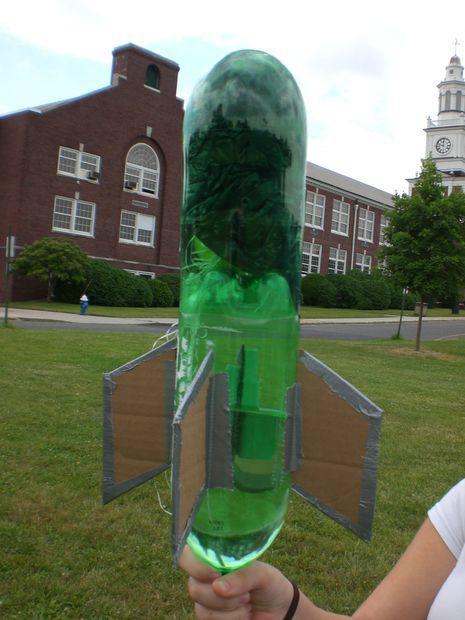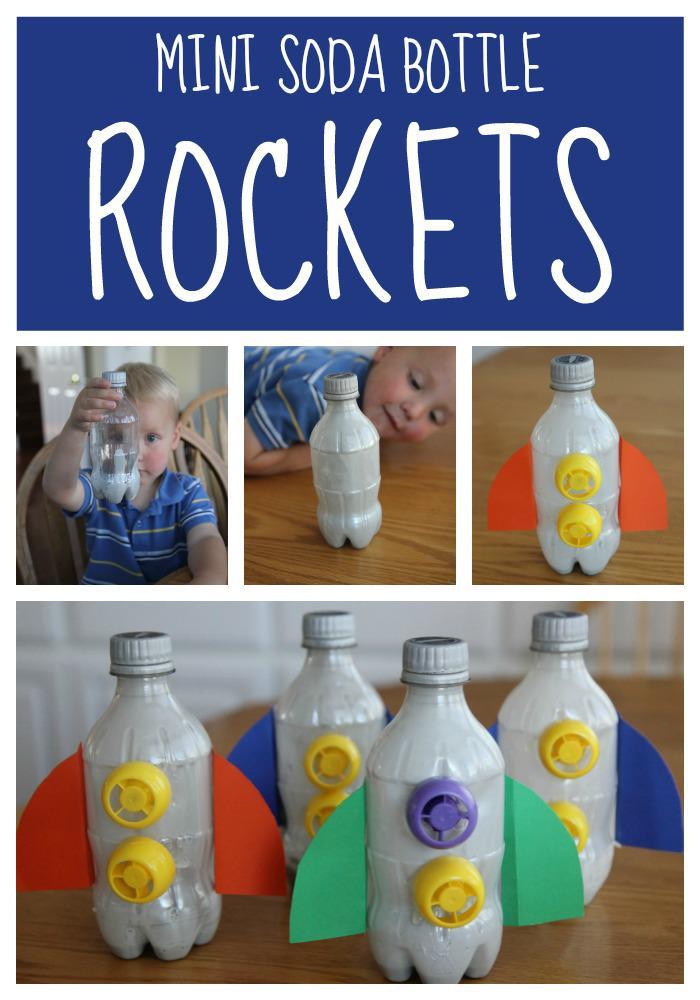The first image is the image on the left, the second image is the image on the right. Assess this claim about the two images: "A person is holding the bottle rocket in one of the images.". Correct or not? Answer yes or no. Yes. The first image is the image on the left, the second image is the image on the right. Given the left and right images, does the statement "The left image features one inverted bottle with fins on its base to create a rocket ship." hold true? Answer yes or no. Yes. 